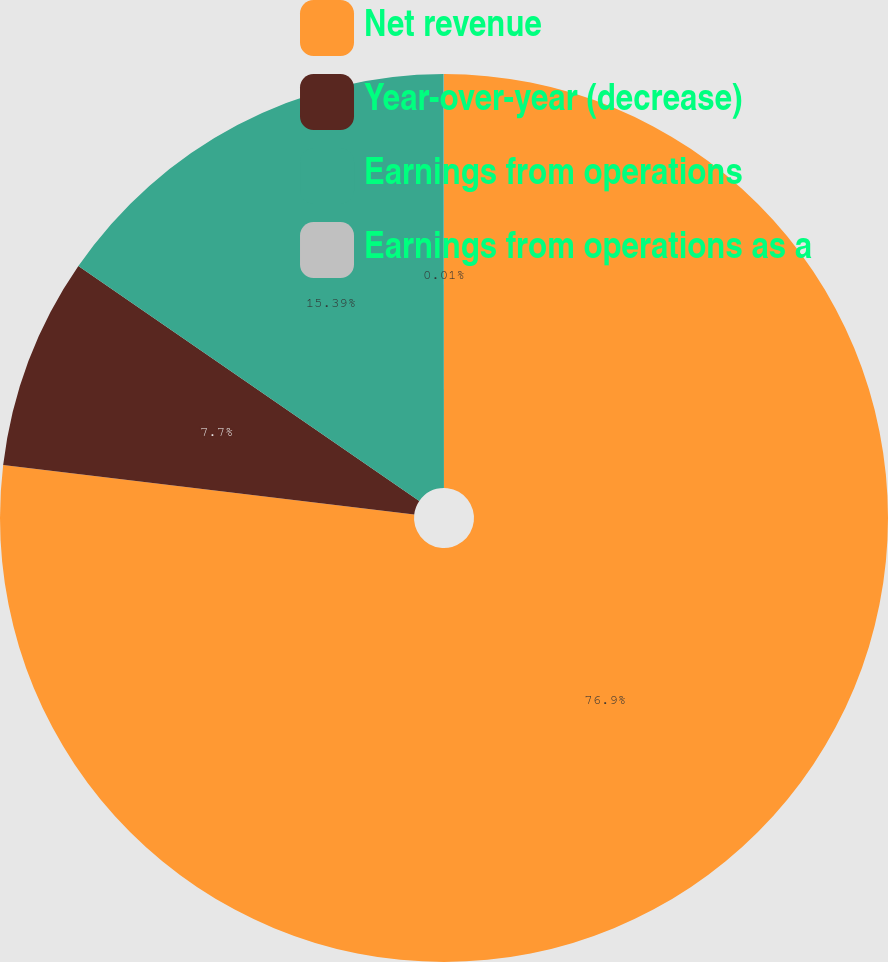<chart> <loc_0><loc_0><loc_500><loc_500><pie_chart><fcel>Net revenue<fcel>Year-over-year (decrease)<fcel>Earnings from operations<fcel>Earnings from operations as a<nl><fcel>76.91%<fcel>7.7%<fcel>15.39%<fcel>0.01%<nl></chart> 